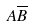Convert formula to latex. <formula><loc_0><loc_0><loc_500><loc_500>A \overline { B }</formula> 